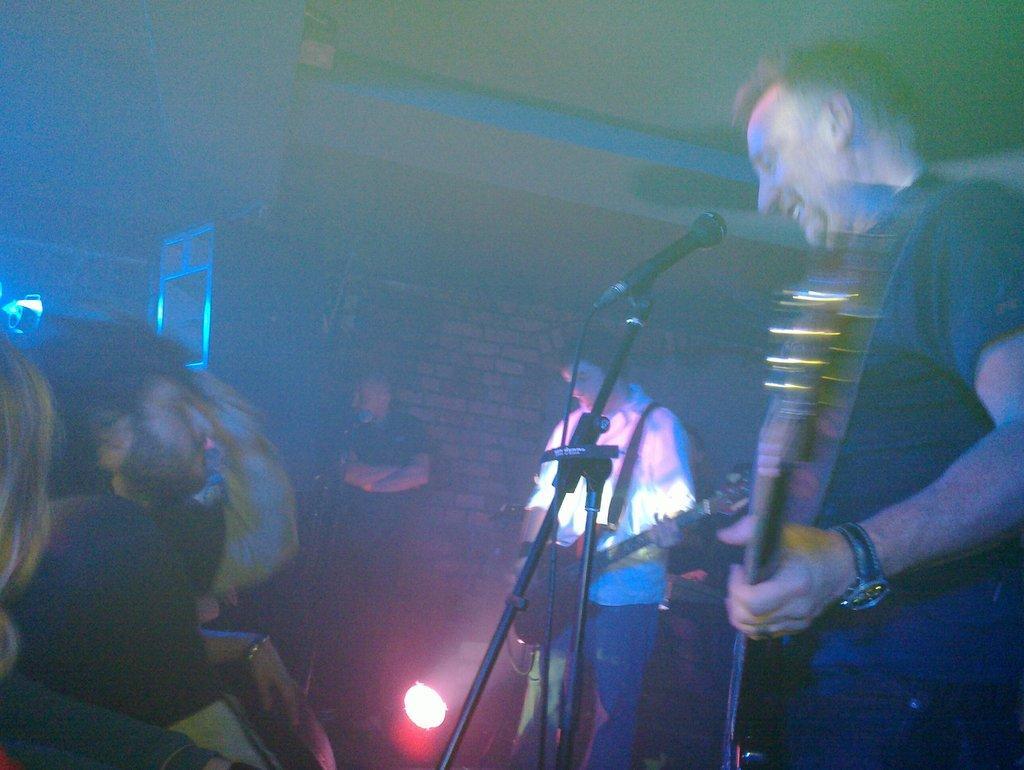Please provide a concise description of this image. This man is playing guitar and smiling. In-front of this man there is a mic with holder. Far this man is standing and playing guitar. On bottom there is a focusing light. These are audience. 